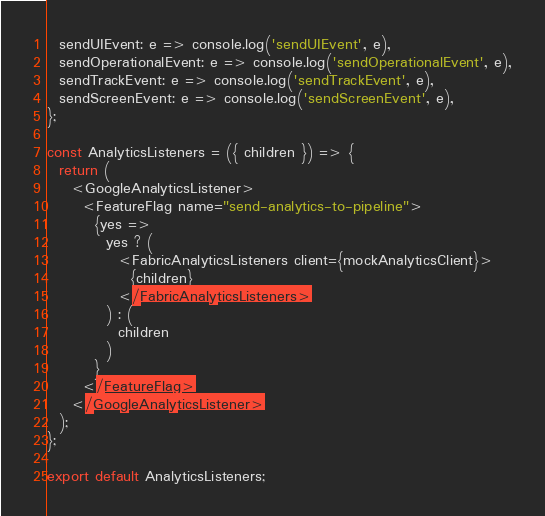<code> <loc_0><loc_0><loc_500><loc_500><_JavaScript_>  sendUIEvent: e => console.log('sendUIEvent', e),
  sendOperationalEvent: e => console.log('sendOperationalEvent', e),
  sendTrackEvent: e => console.log('sendTrackEvent', e),
  sendScreenEvent: e => console.log('sendScreenEvent', e),
};

const AnalyticsListeners = ({ children }) => {
  return (
    <GoogleAnalyticsListener>
      <FeatureFlag name="send-analytics-to-pipeline">
        {yes =>
          yes ? (
            <FabricAnalyticsListeners client={mockAnalyticsClient}>
              {children}
            </FabricAnalyticsListeners>
          ) : (
            children
          )
        }
      </FeatureFlag>
    </GoogleAnalyticsListener>
  );
};

export default AnalyticsListeners;
</code> 